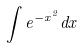<formula> <loc_0><loc_0><loc_500><loc_500>\int e ^ { - x ^ { 2 } } d x</formula> 